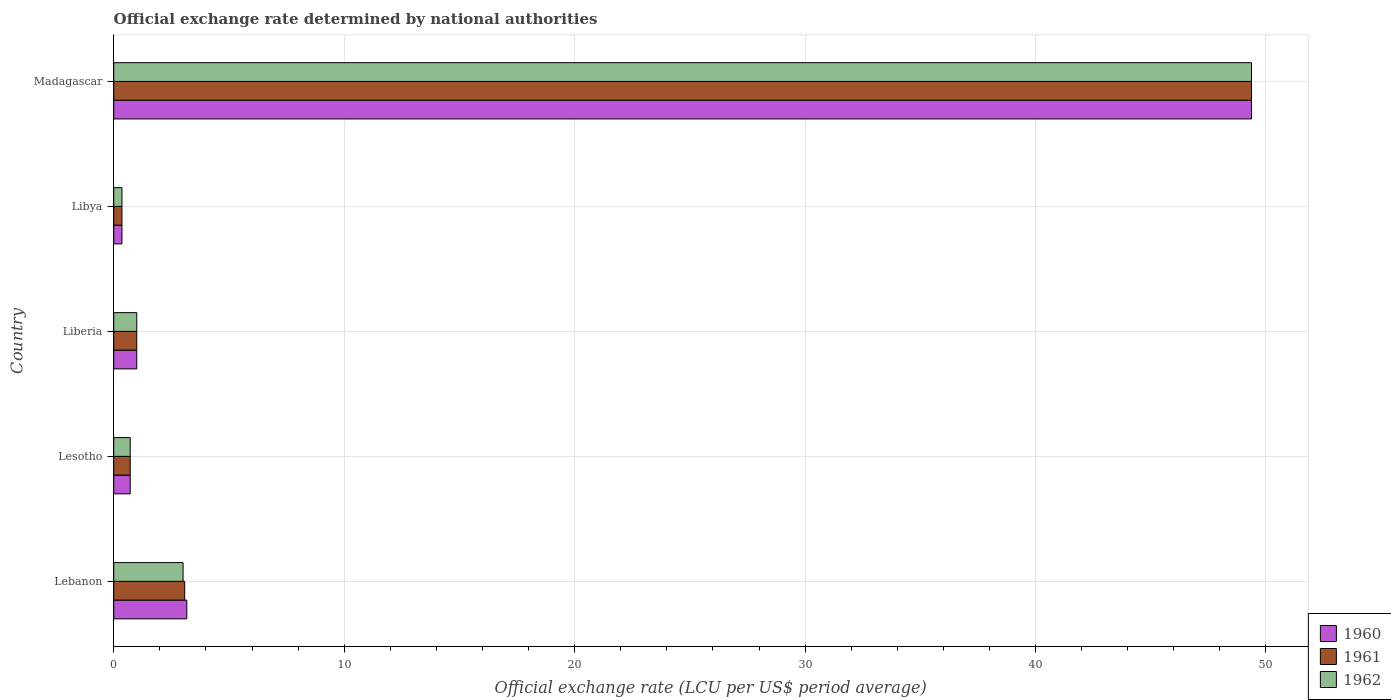Are the number of bars on each tick of the Y-axis equal?
Give a very brief answer. Yes. How many bars are there on the 4th tick from the top?
Provide a succinct answer. 3. What is the label of the 2nd group of bars from the top?
Give a very brief answer. Libya. What is the official exchange rate in 1960 in Lebanon?
Give a very brief answer. 3.17. Across all countries, what is the maximum official exchange rate in 1962?
Make the answer very short. 49.37. Across all countries, what is the minimum official exchange rate in 1960?
Give a very brief answer. 0.36. In which country was the official exchange rate in 1962 maximum?
Your answer should be very brief. Madagascar. In which country was the official exchange rate in 1962 minimum?
Your answer should be compact. Libya. What is the total official exchange rate in 1961 in the graph?
Your answer should be compact. 54.52. What is the difference between the official exchange rate in 1961 in Lesotho and that in Liberia?
Offer a very short reply. -0.29. What is the difference between the official exchange rate in 1960 in Lesotho and the official exchange rate in 1961 in Libya?
Make the answer very short. 0.36. What is the average official exchange rate in 1961 per country?
Provide a short and direct response. 10.9. In how many countries, is the official exchange rate in 1962 greater than 48 LCU?
Keep it short and to the point. 1. What is the ratio of the official exchange rate in 1962 in Lesotho to that in Liberia?
Your answer should be compact. 0.71. Is the difference between the official exchange rate in 1961 in Lesotho and Madagascar greater than the difference between the official exchange rate in 1962 in Lesotho and Madagascar?
Your response must be concise. No. What is the difference between the highest and the second highest official exchange rate in 1962?
Your answer should be compact. 46.36. What is the difference between the highest and the lowest official exchange rate in 1960?
Provide a short and direct response. 49.01. In how many countries, is the official exchange rate in 1960 greater than the average official exchange rate in 1960 taken over all countries?
Your answer should be very brief. 1. What does the 3rd bar from the top in Libya represents?
Provide a short and direct response. 1960. What does the 3rd bar from the bottom in Madagascar represents?
Give a very brief answer. 1962. How many bars are there?
Offer a terse response. 15. Are all the bars in the graph horizontal?
Provide a short and direct response. Yes. How are the legend labels stacked?
Offer a very short reply. Vertical. What is the title of the graph?
Your response must be concise. Official exchange rate determined by national authorities. What is the label or title of the X-axis?
Your answer should be compact. Official exchange rate (LCU per US$ period average). What is the label or title of the Y-axis?
Offer a terse response. Country. What is the Official exchange rate (LCU per US$ period average) in 1960 in Lebanon?
Give a very brief answer. 3.17. What is the Official exchange rate (LCU per US$ period average) of 1961 in Lebanon?
Ensure brevity in your answer.  3.08. What is the Official exchange rate (LCU per US$ period average) of 1962 in Lebanon?
Ensure brevity in your answer.  3.01. What is the Official exchange rate (LCU per US$ period average) of 1960 in Lesotho?
Keep it short and to the point. 0.71. What is the Official exchange rate (LCU per US$ period average) of 1961 in Lesotho?
Make the answer very short. 0.71. What is the Official exchange rate (LCU per US$ period average) in 1962 in Lesotho?
Provide a short and direct response. 0.71. What is the Official exchange rate (LCU per US$ period average) of 1962 in Liberia?
Your answer should be compact. 1. What is the Official exchange rate (LCU per US$ period average) in 1960 in Libya?
Give a very brief answer. 0.36. What is the Official exchange rate (LCU per US$ period average) in 1961 in Libya?
Offer a very short reply. 0.36. What is the Official exchange rate (LCU per US$ period average) of 1962 in Libya?
Provide a succinct answer. 0.36. What is the Official exchange rate (LCU per US$ period average) in 1960 in Madagascar?
Make the answer very short. 49.37. What is the Official exchange rate (LCU per US$ period average) of 1961 in Madagascar?
Make the answer very short. 49.37. What is the Official exchange rate (LCU per US$ period average) in 1962 in Madagascar?
Ensure brevity in your answer.  49.37. Across all countries, what is the maximum Official exchange rate (LCU per US$ period average) in 1960?
Make the answer very short. 49.37. Across all countries, what is the maximum Official exchange rate (LCU per US$ period average) of 1961?
Give a very brief answer. 49.37. Across all countries, what is the maximum Official exchange rate (LCU per US$ period average) in 1962?
Ensure brevity in your answer.  49.37. Across all countries, what is the minimum Official exchange rate (LCU per US$ period average) of 1960?
Keep it short and to the point. 0.36. Across all countries, what is the minimum Official exchange rate (LCU per US$ period average) in 1961?
Keep it short and to the point. 0.36. Across all countries, what is the minimum Official exchange rate (LCU per US$ period average) in 1962?
Keep it short and to the point. 0.36. What is the total Official exchange rate (LCU per US$ period average) in 1960 in the graph?
Offer a very short reply. 54.61. What is the total Official exchange rate (LCU per US$ period average) of 1961 in the graph?
Offer a terse response. 54.52. What is the total Official exchange rate (LCU per US$ period average) in 1962 in the graph?
Your response must be concise. 54.45. What is the difference between the Official exchange rate (LCU per US$ period average) in 1960 in Lebanon and that in Lesotho?
Your answer should be very brief. 2.46. What is the difference between the Official exchange rate (LCU per US$ period average) of 1961 in Lebanon and that in Lesotho?
Provide a short and direct response. 2.36. What is the difference between the Official exchange rate (LCU per US$ period average) of 1962 in Lebanon and that in Lesotho?
Your answer should be very brief. 2.29. What is the difference between the Official exchange rate (LCU per US$ period average) of 1960 in Lebanon and that in Liberia?
Your answer should be very brief. 2.17. What is the difference between the Official exchange rate (LCU per US$ period average) in 1961 in Lebanon and that in Liberia?
Offer a terse response. 2.08. What is the difference between the Official exchange rate (LCU per US$ period average) in 1962 in Lebanon and that in Liberia?
Your answer should be very brief. 2.01. What is the difference between the Official exchange rate (LCU per US$ period average) in 1960 in Lebanon and that in Libya?
Keep it short and to the point. 2.81. What is the difference between the Official exchange rate (LCU per US$ period average) of 1961 in Lebanon and that in Libya?
Provide a short and direct response. 2.72. What is the difference between the Official exchange rate (LCU per US$ period average) in 1962 in Lebanon and that in Libya?
Provide a short and direct response. 2.65. What is the difference between the Official exchange rate (LCU per US$ period average) in 1960 in Lebanon and that in Madagascar?
Offer a terse response. -46.2. What is the difference between the Official exchange rate (LCU per US$ period average) of 1961 in Lebanon and that in Madagascar?
Ensure brevity in your answer.  -46.29. What is the difference between the Official exchange rate (LCU per US$ period average) in 1962 in Lebanon and that in Madagascar?
Offer a terse response. -46.36. What is the difference between the Official exchange rate (LCU per US$ period average) of 1960 in Lesotho and that in Liberia?
Provide a succinct answer. -0.29. What is the difference between the Official exchange rate (LCU per US$ period average) of 1961 in Lesotho and that in Liberia?
Offer a very short reply. -0.29. What is the difference between the Official exchange rate (LCU per US$ period average) of 1962 in Lesotho and that in Liberia?
Give a very brief answer. -0.29. What is the difference between the Official exchange rate (LCU per US$ period average) of 1960 in Lesotho and that in Libya?
Ensure brevity in your answer.  0.36. What is the difference between the Official exchange rate (LCU per US$ period average) in 1961 in Lesotho and that in Libya?
Make the answer very short. 0.36. What is the difference between the Official exchange rate (LCU per US$ period average) of 1962 in Lesotho and that in Libya?
Offer a terse response. 0.36. What is the difference between the Official exchange rate (LCU per US$ period average) in 1960 in Lesotho and that in Madagascar?
Your answer should be very brief. -48.66. What is the difference between the Official exchange rate (LCU per US$ period average) of 1961 in Lesotho and that in Madagascar?
Your response must be concise. -48.66. What is the difference between the Official exchange rate (LCU per US$ period average) of 1962 in Lesotho and that in Madagascar?
Your answer should be compact. -48.66. What is the difference between the Official exchange rate (LCU per US$ period average) in 1960 in Liberia and that in Libya?
Provide a succinct answer. 0.64. What is the difference between the Official exchange rate (LCU per US$ period average) in 1961 in Liberia and that in Libya?
Offer a very short reply. 0.64. What is the difference between the Official exchange rate (LCU per US$ period average) of 1962 in Liberia and that in Libya?
Your answer should be very brief. 0.64. What is the difference between the Official exchange rate (LCU per US$ period average) in 1960 in Liberia and that in Madagascar?
Ensure brevity in your answer.  -48.37. What is the difference between the Official exchange rate (LCU per US$ period average) in 1961 in Liberia and that in Madagascar?
Your answer should be compact. -48.37. What is the difference between the Official exchange rate (LCU per US$ period average) in 1962 in Liberia and that in Madagascar?
Make the answer very short. -48.37. What is the difference between the Official exchange rate (LCU per US$ period average) of 1960 in Libya and that in Madagascar?
Keep it short and to the point. -49.01. What is the difference between the Official exchange rate (LCU per US$ period average) in 1961 in Libya and that in Madagascar?
Give a very brief answer. -49.01. What is the difference between the Official exchange rate (LCU per US$ period average) in 1962 in Libya and that in Madagascar?
Your answer should be very brief. -49.01. What is the difference between the Official exchange rate (LCU per US$ period average) of 1960 in Lebanon and the Official exchange rate (LCU per US$ period average) of 1961 in Lesotho?
Offer a terse response. 2.46. What is the difference between the Official exchange rate (LCU per US$ period average) of 1960 in Lebanon and the Official exchange rate (LCU per US$ period average) of 1962 in Lesotho?
Make the answer very short. 2.46. What is the difference between the Official exchange rate (LCU per US$ period average) in 1961 in Lebanon and the Official exchange rate (LCU per US$ period average) in 1962 in Lesotho?
Keep it short and to the point. 2.36. What is the difference between the Official exchange rate (LCU per US$ period average) of 1960 in Lebanon and the Official exchange rate (LCU per US$ period average) of 1961 in Liberia?
Make the answer very short. 2.17. What is the difference between the Official exchange rate (LCU per US$ period average) in 1960 in Lebanon and the Official exchange rate (LCU per US$ period average) in 1962 in Liberia?
Offer a very short reply. 2.17. What is the difference between the Official exchange rate (LCU per US$ period average) in 1961 in Lebanon and the Official exchange rate (LCU per US$ period average) in 1962 in Liberia?
Provide a succinct answer. 2.08. What is the difference between the Official exchange rate (LCU per US$ period average) of 1960 in Lebanon and the Official exchange rate (LCU per US$ period average) of 1961 in Libya?
Your response must be concise. 2.81. What is the difference between the Official exchange rate (LCU per US$ period average) in 1960 in Lebanon and the Official exchange rate (LCU per US$ period average) in 1962 in Libya?
Provide a succinct answer. 2.81. What is the difference between the Official exchange rate (LCU per US$ period average) in 1961 in Lebanon and the Official exchange rate (LCU per US$ period average) in 1962 in Libya?
Keep it short and to the point. 2.72. What is the difference between the Official exchange rate (LCU per US$ period average) in 1960 in Lebanon and the Official exchange rate (LCU per US$ period average) in 1961 in Madagascar?
Offer a terse response. -46.2. What is the difference between the Official exchange rate (LCU per US$ period average) of 1960 in Lebanon and the Official exchange rate (LCU per US$ period average) of 1962 in Madagascar?
Ensure brevity in your answer.  -46.2. What is the difference between the Official exchange rate (LCU per US$ period average) of 1961 in Lebanon and the Official exchange rate (LCU per US$ period average) of 1962 in Madagascar?
Provide a short and direct response. -46.29. What is the difference between the Official exchange rate (LCU per US$ period average) of 1960 in Lesotho and the Official exchange rate (LCU per US$ period average) of 1961 in Liberia?
Your response must be concise. -0.29. What is the difference between the Official exchange rate (LCU per US$ period average) of 1960 in Lesotho and the Official exchange rate (LCU per US$ period average) of 1962 in Liberia?
Provide a succinct answer. -0.29. What is the difference between the Official exchange rate (LCU per US$ period average) of 1961 in Lesotho and the Official exchange rate (LCU per US$ period average) of 1962 in Liberia?
Your answer should be very brief. -0.29. What is the difference between the Official exchange rate (LCU per US$ period average) of 1960 in Lesotho and the Official exchange rate (LCU per US$ period average) of 1961 in Libya?
Provide a succinct answer. 0.36. What is the difference between the Official exchange rate (LCU per US$ period average) of 1960 in Lesotho and the Official exchange rate (LCU per US$ period average) of 1962 in Libya?
Keep it short and to the point. 0.36. What is the difference between the Official exchange rate (LCU per US$ period average) in 1961 in Lesotho and the Official exchange rate (LCU per US$ period average) in 1962 in Libya?
Make the answer very short. 0.36. What is the difference between the Official exchange rate (LCU per US$ period average) of 1960 in Lesotho and the Official exchange rate (LCU per US$ period average) of 1961 in Madagascar?
Provide a short and direct response. -48.66. What is the difference between the Official exchange rate (LCU per US$ period average) of 1960 in Lesotho and the Official exchange rate (LCU per US$ period average) of 1962 in Madagascar?
Your answer should be very brief. -48.66. What is the difference between the Official exchange rate (LCU per US$ period average) of 1961 in Lesotho and the Official exchange rate (LCU per US$ period average) of 1962 in Madagascar?
Ensure brevity in your answer.  -48.66. What is the difference between the Official exchange rate (LCU per US$ period average) of 1960 in Liberia and the Official exchange rate (LCU per US$ period average) of 1961 in Libya?
Your answer should be very brief. 0.64. What is the difference between the Official exchange rate (LCU per US$ period average) in 1960 in Liberia and the Official exchange rate (LCU per US$ period average) in 1962 in Libya?
Give a very brief answer. 0.64. What is the difference between the Official exchange rate (LCU per US$ period average) of 1961 in Liberia and the Official exchange rate (LCU per US$ period average) of 1962 in Libya?
Ensure brevity in your answer.  0.64. What is the difference between the Official exchange rate (LCU per US$ period average) in 1960 in Liberia and the Official exchange rate (LCU per US$ period average) in 1961 in Madagascar?
Provide a succinct answer. -48.37. What is the difference between the Official exchange rate (LCU per US$ period average) in 1960 in Liberia and the Official exchange rate (LCU per US$ period average) in 1962 in Madagascar?
Provide a short and direct response. -48.37. What is the difference between the Official exchange rate (LCU per US$ period average) of 1961 in Liberia and the Official exchange rate (LCU per US$ period average) of 1962 in Madagascar?
Keep it short and to the point. -48.37. What is the difference between the Official exchange rate (LCU per US$ period average) of 1960 in Libya and the Official exchange rate (LCU per US$ period average) of 1961 in Madagascar?
Ensure brevity in your answer.  -49.01. What is the difference between the Official exchange rate (LCU per US$ period average) of 1960 in Libya and the Official exchange rate (LCU per US$ period average) of 1962 in Madagascar?
Offer a terse response. -49.01. What is the difference between the Official exchange rate (LCU per US$ period average) in 1961 in Libya and the Official exchange rate (LCU per US$ period average) in 1962 in Madagascar?
Offer a very short reply. -49.01. What is the average Official exchange rate (LCU per US$ period average) of 1960 per country?
Offer a terse response. 10.92. What is the average Official exchange rate (LCU per US$ period average) in 1961 per country?
Give a very brief answer. 10.9. What is the average Official exchange rate (LCU per US$ period average) in 1962 per country?
Your response must be concise. 10.89. What is the difference between the Official exchange rate (LCU per US$ period average) of 1960 and Official exchange rate (LCU per US$ period average) of 1961 in Lebanon?
Keep it short and to the point. 0.09. What is the difference between the Official exchange rate (LCU per US$ period average) of 1960 and Official exchange rate (LCU per US$ period average) of 1962 in Lebanon?
Your response must be concise. 0.16. What is the difference between the Official exchange rate (LCU per US$ period average) of 1961 and Official exchange rate (LCU per US$ period average) of 1962 in Lebanon?
Your answer should be compact. 0.07. What is the difference between the Official exchange rate (LCU per US$ period average) in 1960 and Official exchange rate (LCU per US$ period average) in 1961 in Lesotho?
Your response must be concise. 0. What is the difference between the Official exchange rate (LCU per US$ period average) of 1960 and Official exchange rate (LCU per US$ period average) of 1962 in Lesotho?
Make the answer very short. 0. What is the difference between the Official exchange rate (LCU per US$ period average) of 1961 and Official exchange rate (LCU per US$ period average) of 1962 in Lesotho?
Your response must be concise. 0. What is the difference between the Official exchange rate (LCU per US$ period average) in 1960 and Official exchange rate (LCU per US$ period average) in 1961 in Liberia?
Provide a succinct answer. 0. What is the difference between the Official exchange rate (LCU per US$ period average) of 1961 and Official exchange rate (LCU per US$ period average) of 1962 in Liberia?
Provide a short and direct response. 0. What is the difference between the Official exchange rate (LCU per US$ period average) in 1961 and Official exchange rate (LCU per US$ period average) in 1962 in Libya?
Keep it short and to the point. 0. What is the difference between the Official exchange rate (LCU per US$ period average) of 1960 and Official exchange rate (LCU per US$ period average) of 1961 in Madagascar?
Provide a short and direct response. 0. What is the difference between the Official exchange rate (LCU per US$ period average) in 1961 and Official exchange rate (LCU per US$ period average) in 1962 in Madagascar?
Make the answer very short. 0. What is the ratio of the Official exchange rate (LCU per US$ period average) in 1960 in Lebanon to that in Lesotho?
Offer a very short reply. 4.44. What is the ratio of the Official exchange rate (LCU per US$ period average) in 1961 in Lebanon to that in Lesotho?
Ensure brevity in your answer.  4.31. What is the ratio of the Official exchange rate (LCU per US$ period average) in 1962 in Lebanon to that in Lesotho?
Provide a short and direct response. 4.21. What is the ratio of the Official exchange rate (LCU per US$ period average) of 1960 in Lebanon to that in Liberia?
Your response must be concise. 3.17. What is the ratio of the Official exchange rate (LCU per US$ period average) of 1961 in Lebanon to that in Liberia?
Your answer should be compact. 3.08. What is the ratio of the Official exchange rate (LCU per US$ period average) in 1962 in Lebanon to that in Liberia?
Your answer should be very brief. 3.01. What is the ratio of the Official exchange rate (LCU per US$ period average) of 1960 in Lebanon to that in Libya?
Your response must be concise. 8.87. What is the ratio of the Official exchange rate (LCU per US$ period average) of 1961 in Lebanon to that in Libya?
Your answer should be very brief. 8.62. What is the ratio of the Official exchange rate (LCU per US$ period average) in 1962 in Lebanon to that in Libya?
Offer a terse response. 8.43. What is the ratio of the Official exchange rate (LCU per US$ period average) in 1960 in Lebanon to that in Madagascar?
Your answer should be very brief. 0.06. What is the ratio of the Official exchange rate (LCU per US$ period average) of 1961 in Lebanon to that in Madagascar?
Offer a very short reply. 0.06. What is the ratio of the Official exchange rate (LCU per US$ period average) of 1962 in Lebanon to that in Madagascar?
Provide a short and direct response. 0.06. What is the ratio of the Official exchange rate (LCU per US$ period average) in 1960 in Lesotho to that in Liberia?
Your answer should be compact. 0.71. What is the ratio of the Official exchange rate (LCU per US$ period average) of 1962 in Lesotho to that in Liberia?
Provide a short and direct response. 0.71. What is the ratio of the Official exchange rate (LCU per US$ period average) of 1960 in Lesotho to that in Madagascar?
Your answer should be very brief. 0.01. What is the ratio of the Official exchange rate (LCU per US$ period average) of 1961 in Lesotho to that in Madagascar?
Offer a very short reply. 0.01. What is the ratio of the Official exchange rate (LCU per US$ period average) of 1962 in Lesotho to that in Madagascar?
Your answer should be compact. 0.01. What is the ratio of the Official exchange rate (LCU per US$ period average) in 1960 in Liberia to that in Libya?
Keep it short and to the point. 2.8. What is the ratio of the Official exchange rate (LCU per US$ period average) of 1960 in Liberia to that in Madagascar?
Your response must be concise. 0.02. What is the ratio of the Official exchange rate (LCU per US$ period average) in 1961 in Liberia to that in Madagascar?
Your answer should be compact. 0.02. What is the ratio of the Official exchange rate (LCU per US$ period average) of 1962 in Liberia to that in Madagascar?
Keep it short and to the point. 0.02. What is the ratio of the Official exchange rate (LCU per US$ period average) in 1960 in Libya to that in Madagascar?
Your response must be concise. 0.01. What is the ratio of the Official exchange rate (LCU per US$ period average) in 1961 in Libya to that in Madagascar?
Your answer should be very brief. 0.01. What is the ratio of the Official exchange rate (LCU per US$ period average) in 1962 in Libya to that in Madagascar?
Ensure brevity in your answer.  0.01. What is the difference between the highest and the second highest Official exchange rate (LCU per US$ period average) of 1960?
Give a very brief answer. 46.2. What is the difference between the highest and the second highest Official exchange rate (LCU per US$ period average) in 1961?
Offer a very short reply. 46.29. What is the difference between the highest and the second highest Official exchange rate (LCU per US$ period average) in 1962?
Your answer should be compact. 46.36. What is the difference between the highest and the lowest Official exchange rate (LCU per US$ period average) in 1960?
Make the answer very short. 49.01. What is the difference between the highest and the lowest Official exchange rate (LCU per US$ period average) in 1961?
Provide a succinct answer. 49.01. What is the difference between the highest and the lowest Official exchange rate (LCU per US$ period average) of 1962?
Offer a very short reply. 49.01. 